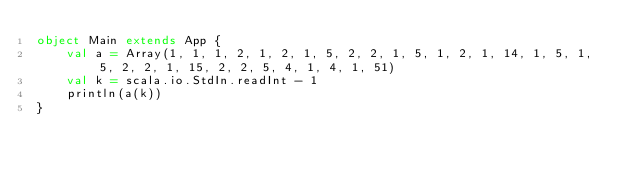<code> <loc_0><loc_0><loc_500><loc_500><_Scala_>object Main extends App {
	val a = Array(1, 1, 1, 2, 1, 2, 1, 5, 2, 2, 1, 5, 1, 2, 1, 14, 1, 5, 1, 5, 2, 2, 1, 15, 2, 2, 5, 4, 1, 4, 1, 51)
	val k = scala.io.StdIn.readInt - 1
	println(a(k))
}</code> 